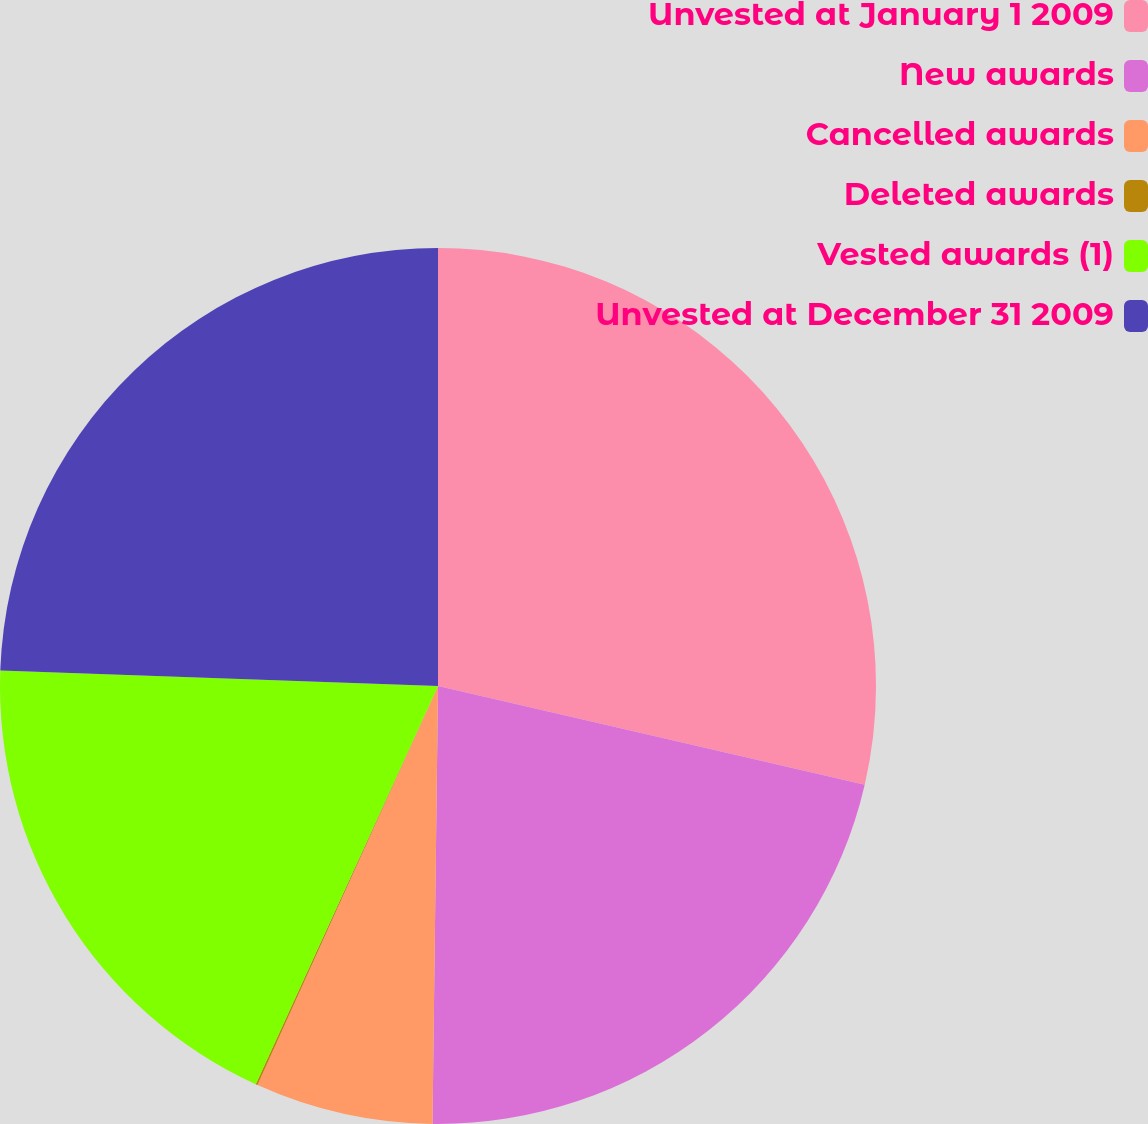Convert chart to OTSL. <chart><loc_0><loc_0><loc_500><loc_500><pie_chart><fcel>Unvested at January 1 2009<fcel>New awards<fcel>Cancelled awards<fcel>Deleted awards<fcel>Vested awards (1)<fcel>Unvested at December 31 2009<nl><fcel>28.62%<fcel>21.58%<fcel>6.56%<fcel>0.07%<fcel>18.73%<fcel>24.44%<nl></chart> 